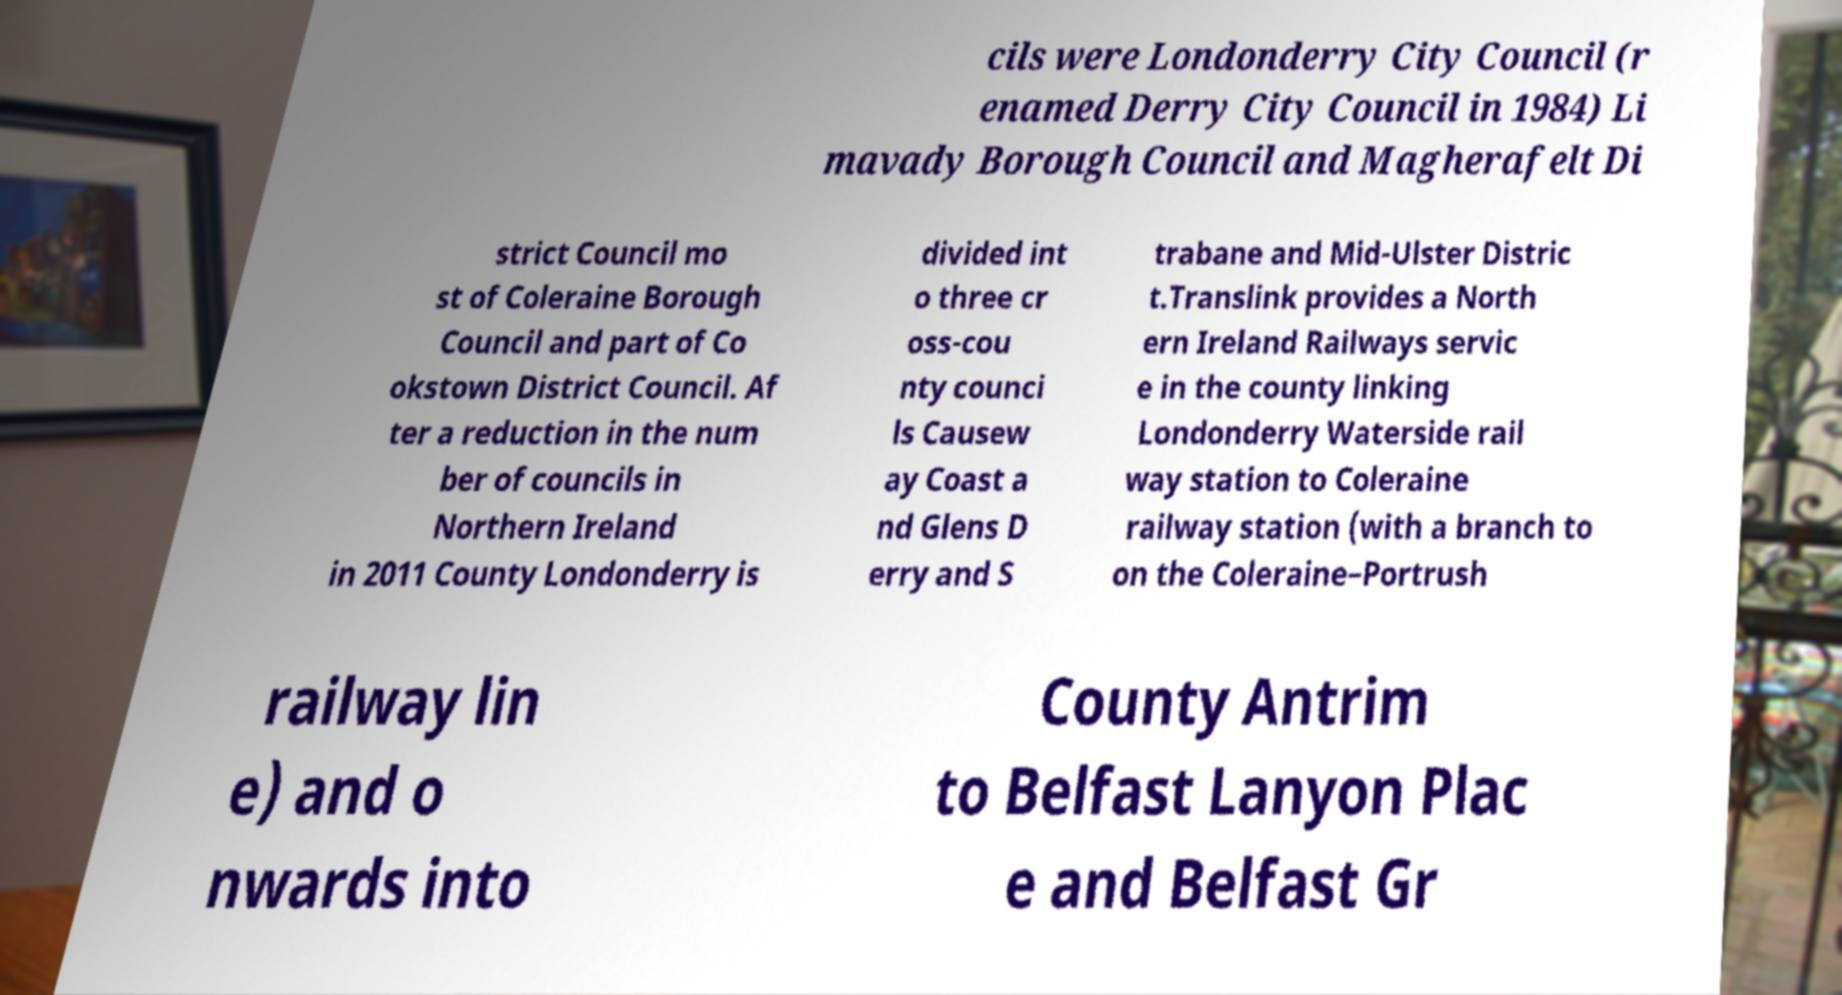Can you accurately transcribe the text from the provided image for me? cils were Londonderry City Council (r enamed Derry City Council in 1984) Li mavady Borough Council and Magherafelt Di strict Council mo st of Coleraine Borough Council and part of Co okstown District Council. Af ter a reduction in the num ber of councils in Northern Ireland in 2011 County Londonderry is divided int o three cr oss-cou nty counci ls Causew ay Coast a nd Glens D erry and S trabane and Mid-Ulster Distric t.Translink provides a North ern Ireland Railways servic e in the county linking Londonderry Waterside rail way station to Coleraine railway station (with a branch to on the Coleraine–Portrush railway lin e) and o nwards into County Antrim to Belfast Lanyon Plac e and Belfast Gr 